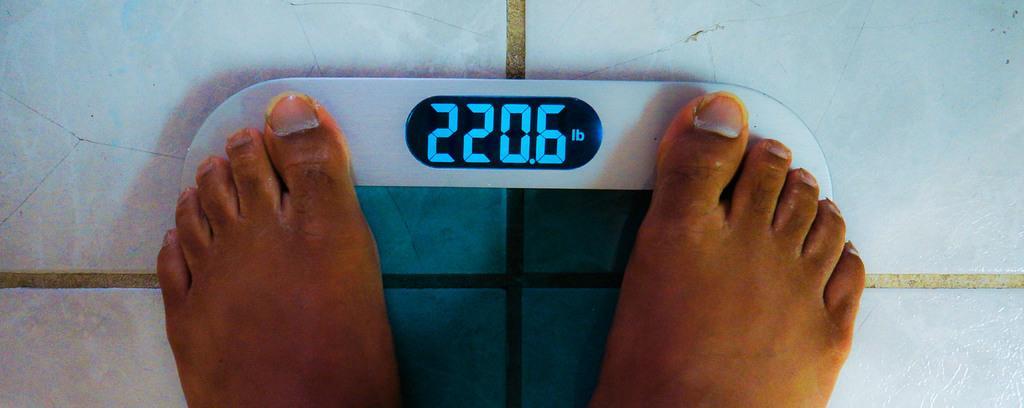Describe this image in one or two sentences. In this image I can see the person's legs on the weight machine and I can see white color background. 